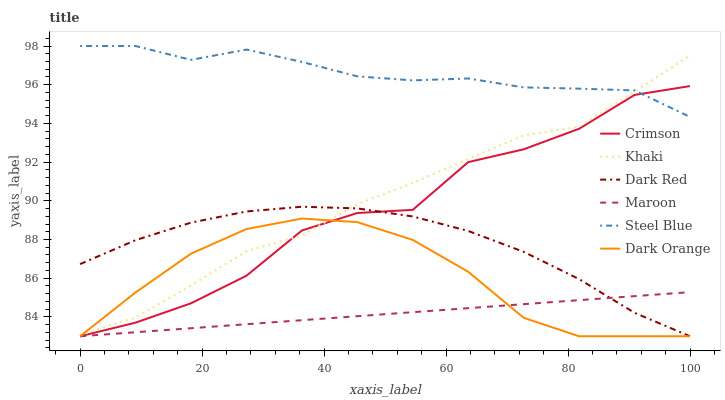Does Maroon have the minimum area under the curve?
Answer yes or no. Yes. Does Steel Blue have the maximum area under the curve?
Answer yes or no. Yes. Does Khaki have the minimum area under the curve?
Answer yes or no. No. Does Khaki have the maximum area under the curve?
Answer yes or no. No. Is Maroon the smoothest?
Answer yes or no. Yes. Is Crimson the roughest?
Answer yes or no. Yes. Is Khaki the smoothest?
Answer yes or no. No. Is Khaki the roughest?
Answer yes or no. No. Does Dark Orange have the lowest value?
Answer yes or no. Yes. Does Khaki have the lowest value?
Answer yes or no. No. Does Steel Blue have the highest value?
Answer yes or no. Yes. Does Khaki have the highest value?
Answer yes or no. No. Is Maroon less than Khaki?
Answer yes or no. Yes. Is Steel Blue greater than Maroon?
Answer yes or no. Yes. Does Dark Orange intersect Khaki?
Answer yes or no. Yes. Is Dark Orange less than Khaki?
Answer yes or no. No. Is Dark Orange greater than Khaki?
Answer yes or no. No. Does Maroon intersect Khaki?
Answer yes or no. No. 